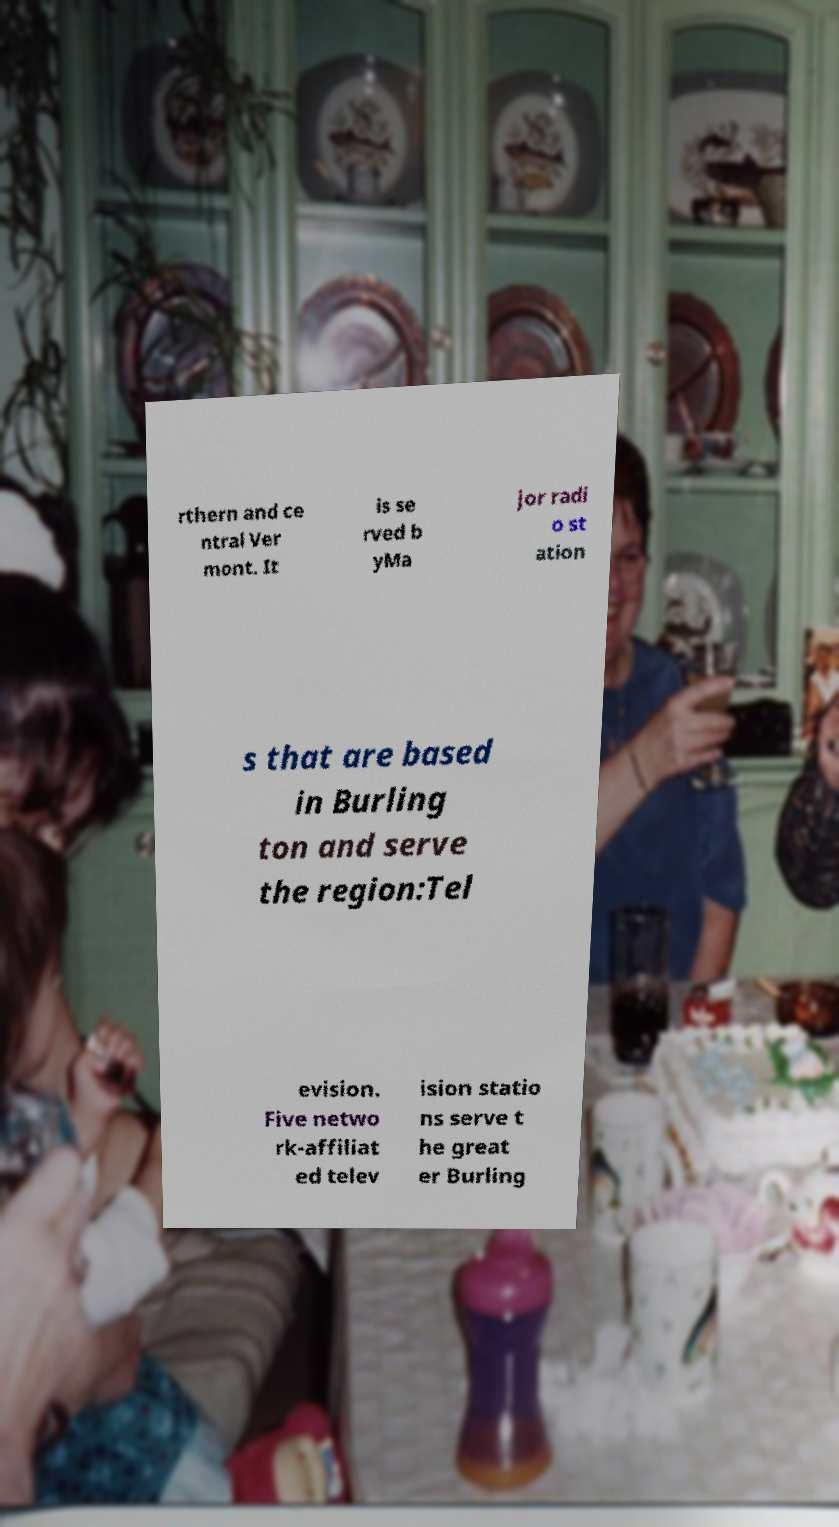What messages or text are displayed in this image? I need them in a readable, typed format. rthern and ce ntral Ver mont. It is se rved b yMa jor radi o st ation s that are based in Burling ton and serve the region:Tel evision. Five netwo rk-affiliat ed telev ision statio ns serve t he great er Burling 